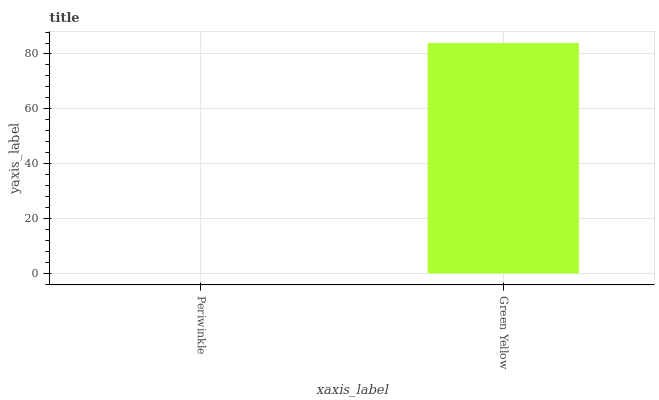Is Green Yellow the minimum?
Answer yes or no. No. Is Green Yellow greater than Periwinkle?
Answer yes or no. Yes. Is Periwinkle less than Green Yellow?
Answer yes or no. Yes. Is Periwinkle greater than Green Yellow?
Answer yes or no. No. Is Green Yellow less than Periwinkle?
Answer yes or no. No. Is Green Yellow the high median?
Answer yes or no. Yes. Is Periwinkle the low median?
Answer yes or no. Yes. Is Periwinkle the high median?
Answer yes or no. No. Is Green Yellow the low median?
Answer yes or no. No. 